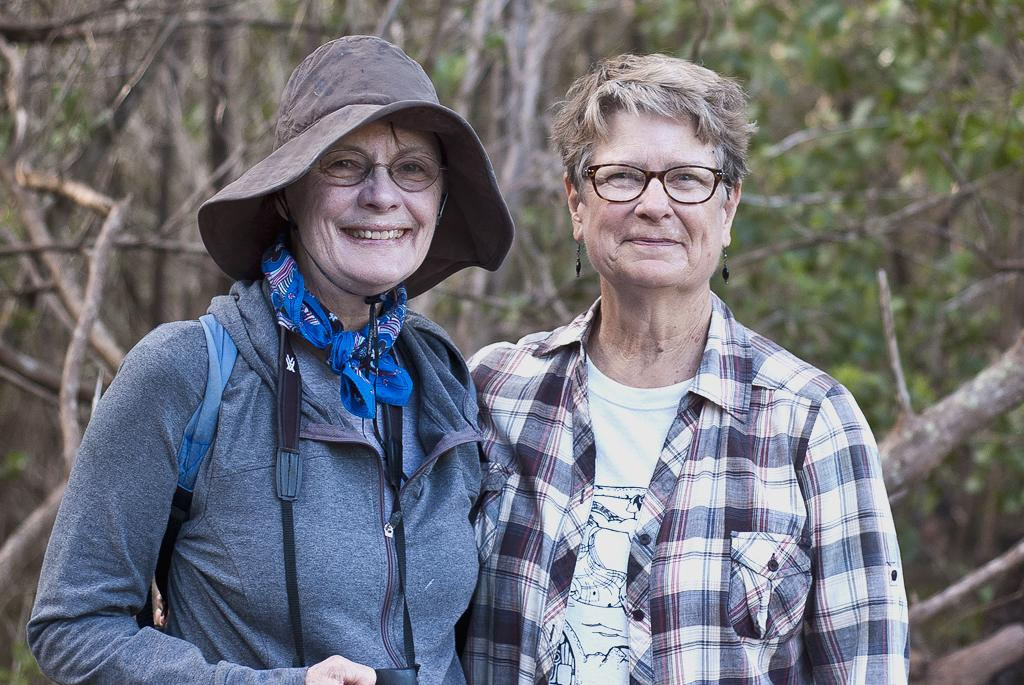How many people are in the image? There are two people in the image. What are the two people doing in the image? The two people are standing in the image. What expressions do the two people have in the image? The two people are smiling in the image. What can be seen in the background of the image? There are trees in the background of the image. What expert advice can be seen in the image? There is no expert advice present in the image; it features two people standing and smiling. What statement can be read from the mind of the person on the left? There is no statement or mind reading present in the image; it only shows two people standing and smiling. 